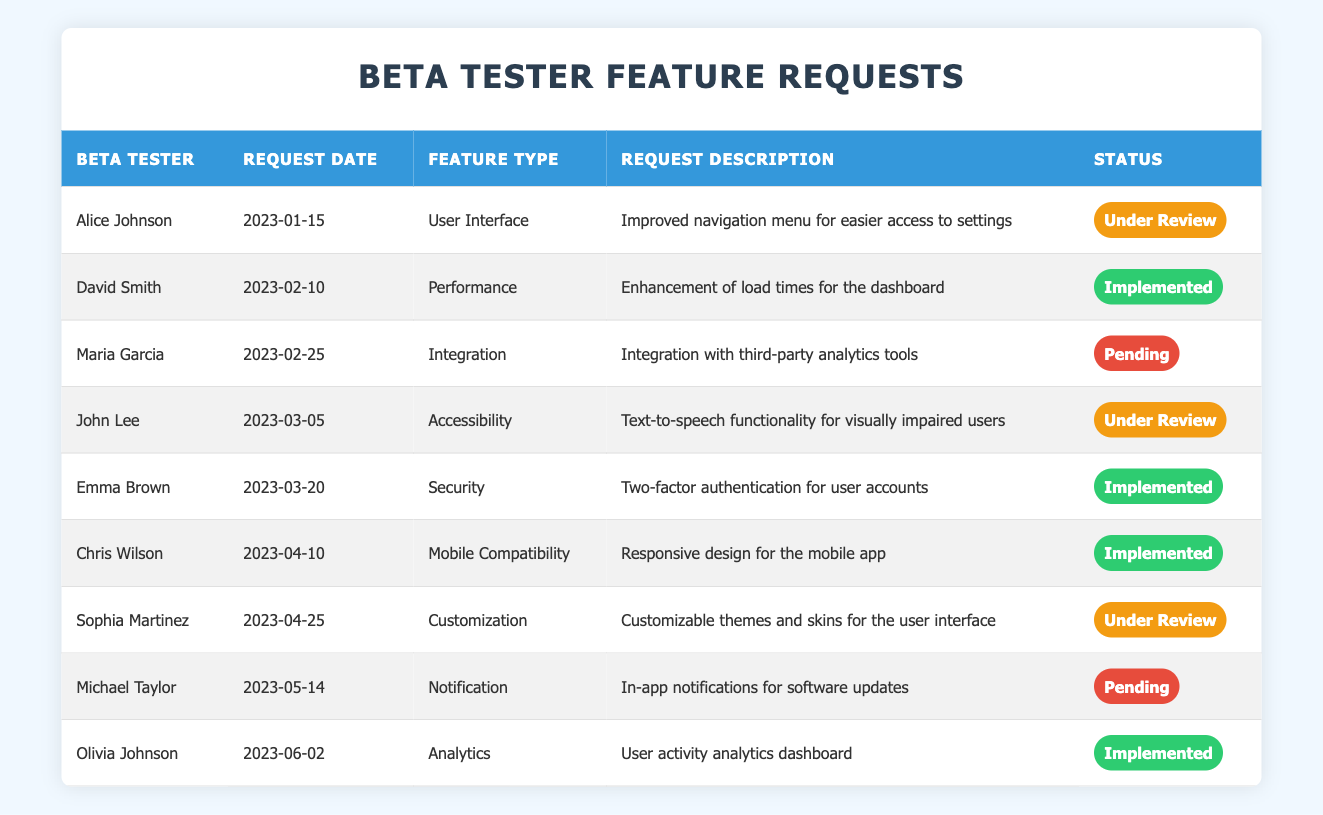What is the total number of feature requests submitted by beta testers? There are 9 rows in the table, each representing a unique feature request. Therefore, the total number of feature requests is simply the count of those rows.
Answer: 9 How many feature requests are currently marked as "Under Review"? Reviewing the status column, there are 3 requests indicated as "Under Review" for the entries from Alice Johnson, John Lee, and Sophia Martinez.
Answer: 3 What type of feature request did Emma Brown submit? Looking at the row for Emma Brown, her feature request is categorized under "Security" as provided in the feature type column.
Answer: Security Which beta tester submitted the request for "In-app notifications for software updates"? Finding the description "In-app notifications for software updates" leads us to the row for Michael Taylor, labeled as the requester in the beta tester column.
Answer: Michael Taylor How many feature requests have been implemented versus those that are pending? Counting the status column, there are 5 requests marked as "Implemented" and 2 requests marked as "Pending." To arrive at the numbers, I summed the requests for each status category.
Answer: Implemented: 5, Pending: 2 Is there a feature request related to "Mobile Compatibility"? Searching through the feature type column, the entry for Chris Wilson matches this category, confirming that it indeed exists in the table.
Answer: Yes How many different feature types are represented in the requests? Reviewing the feature type column, I identify "User Interface," "Performance," "Integration," "Accessibility," "Security," "Mobile Compatibility," "Customization," "Notification," and "Analytics." This totals 9 distinct kinds.
Answer: 9 Which beta tester submitted the earliest feature request and what was the description? The earliest date from the request date column is January 15, 2023, submitted by Alice Johnson, whose request was for an "Improved navigation menu for easier access to settings," gleaned from the description column.
Answer: Alice Johnson, Improved navigation menu for easier access to settings How many feature requests were made after March 20, 2023? Counting the requests made after March 20, 2023, there are 5 recent requests from Chris Wilson, Sophia Martinez, Michael Taylor, and Olivia Johnson, as indicated by their request dates.
Answer: 5 